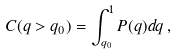<formula> <loc_0><loc_0><loc_500><loc_500>C ( q > q _ { 0 } ) = \int _ { q _ { 0 } } ^ { 1 } P ( q ) d q \, ,</formula> 